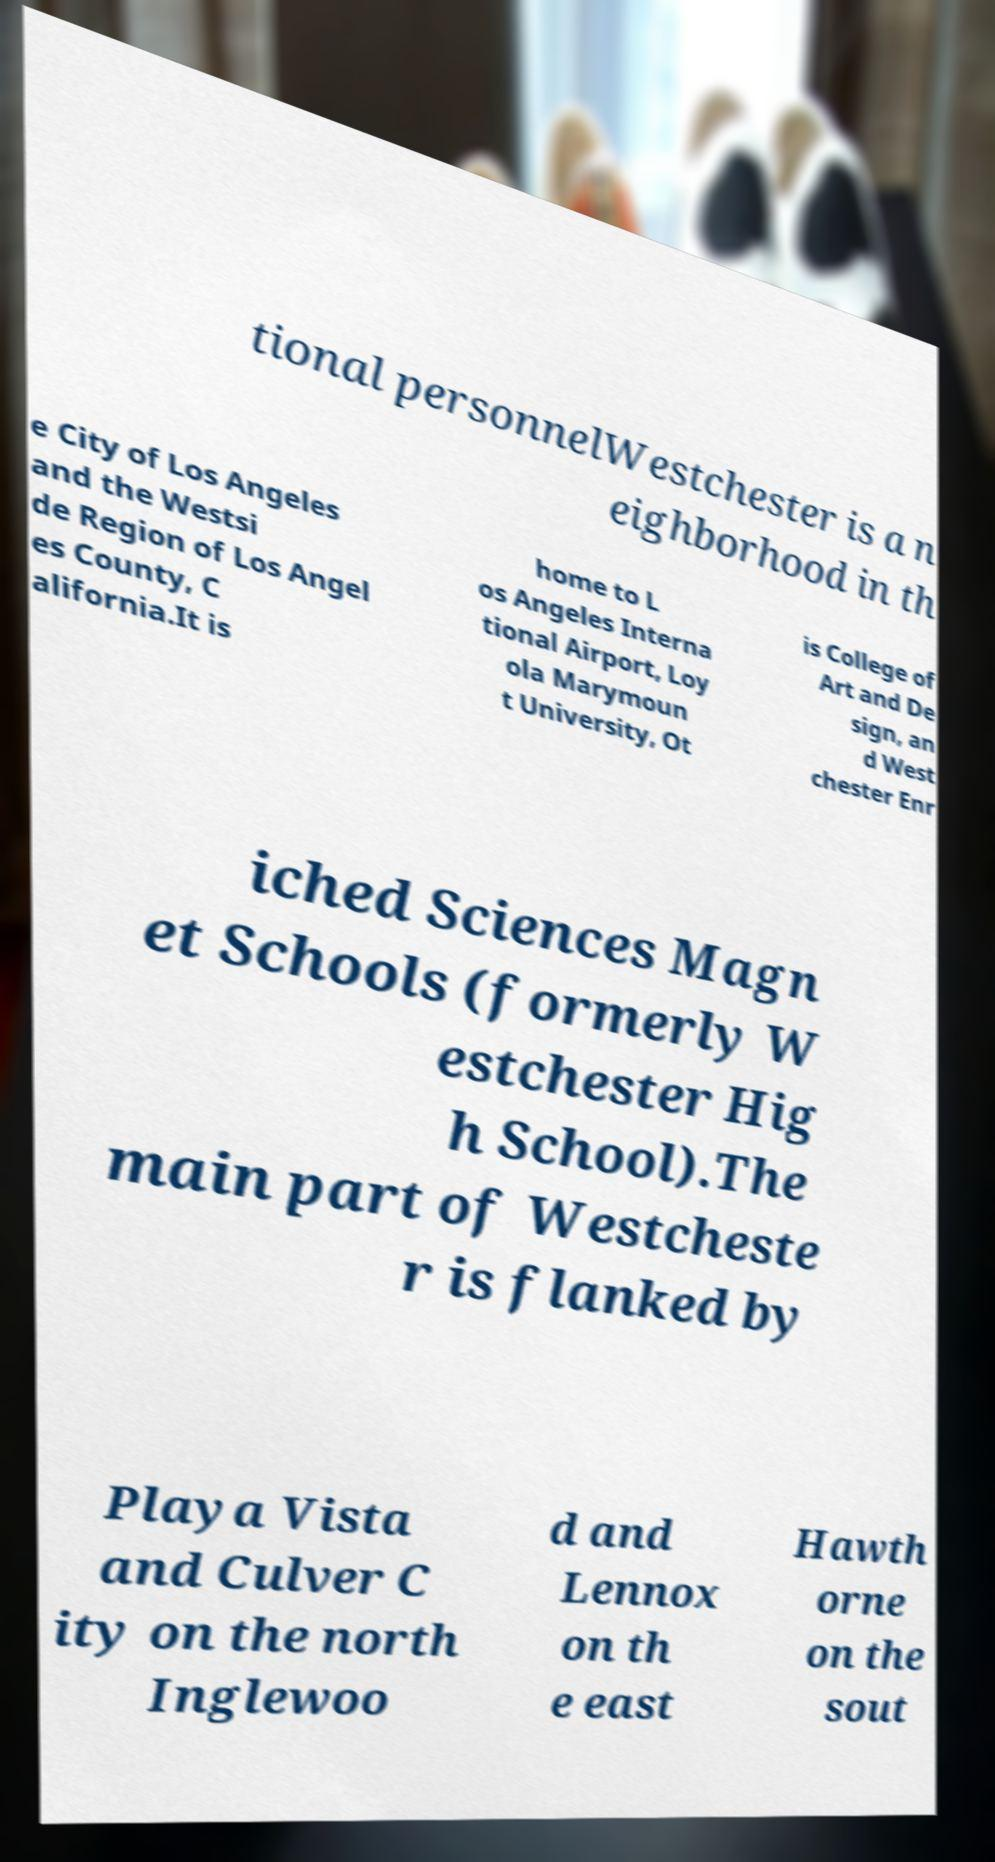Can you read and provide the text displayed in the image?This photo seems to have some interesting text. Can you extract and type it out for me? tional personnelWestchester is a n eighborhood in th e City of Los Angeles and the Westsi de Region of Los Angel es County, C alifornia.It is home to L os Angeles Interna tional Airport, Loy ola Marymoun t University, Ot is College of Art and De sign, an d West chester Enr iched Sciences Magn et Schools (formerly W estchester Hig h School).The main part of Westcheste r is flanked by Playa Vista and Culver C ity on the north Inglewoo d and Lennox on th e east Hawth orne on the sout 